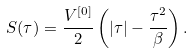<formula> <loc_0><loc_0><loc_500><loc_500>S ( \tau ) = \frac { V ^ { [ 0 ] } } { 2 } \left ( | \tau | - \frac { \tau ^ { 2 } } { \beta } \right ) .</formula> 